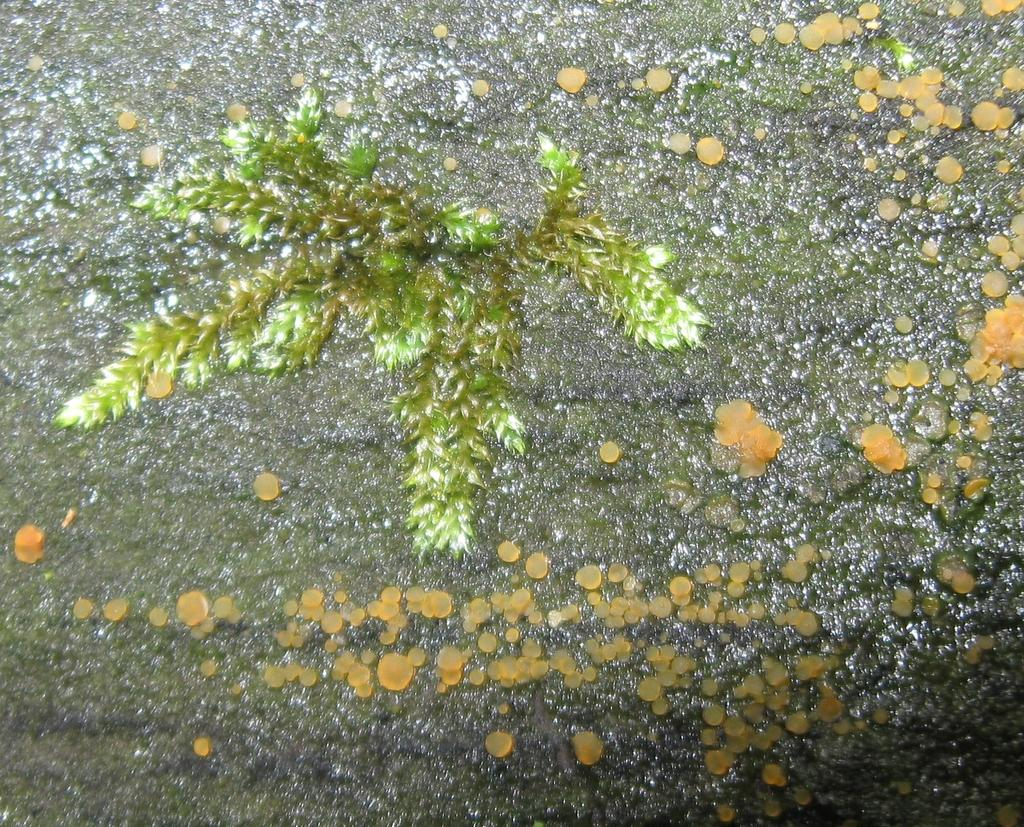What is the main subject of the image? The main subject of the image is a rock. What is growing on the rock? Algae is forming on the rock. Is there any vegetation present on the rock? Yes, there is a plant on the rock. What type of flesh can be seen in the image? There is no flesh present in the image; it features a rock with algae and a plant. What is the rock used for in the image? The rock is not being used for any specific purpose in the image; it is simply a natural subject being observed. 